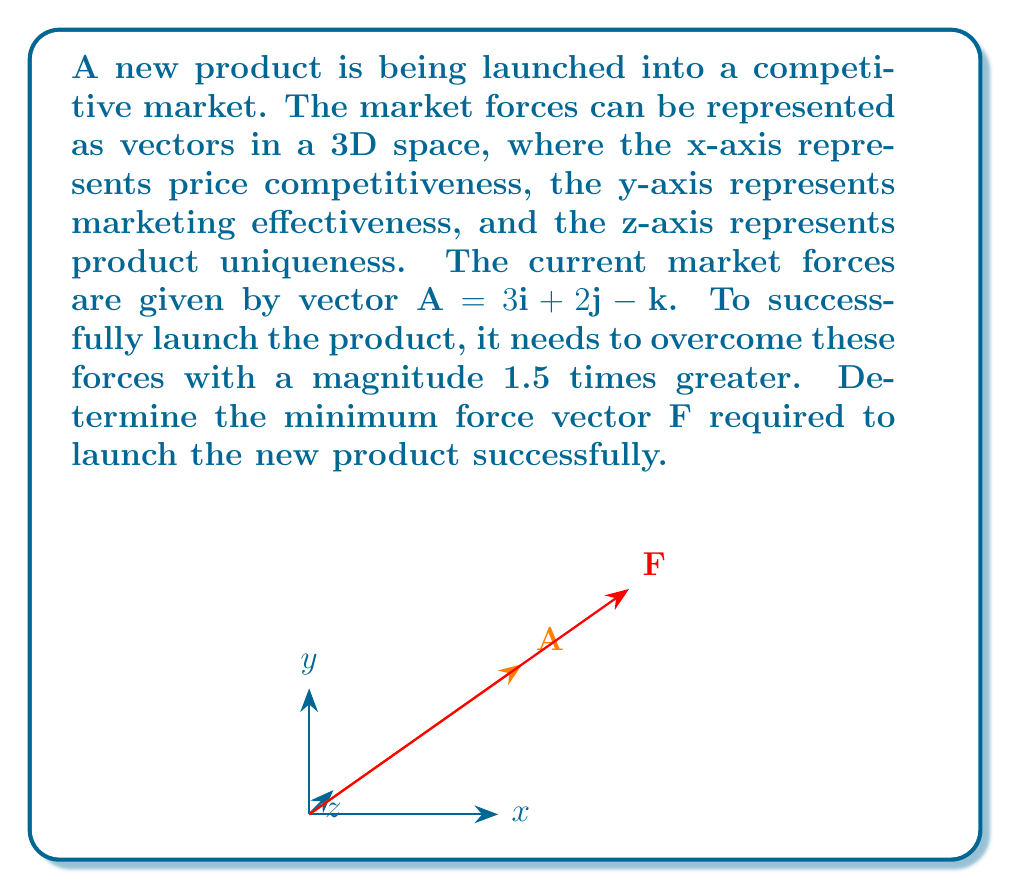Provide a solution to this math problem. Let's approach this step-by-step:

1) First, we need to calculate the magnitude of the current market forces vector $\mathbf{A}$:

   $|\mathbf{A}| = \sqrt{3^2 + 2^2 + (-1)^2} = \sqrt{9 + 4 + 1} = \sqrt{14}$

2) The required force needs to have a magnitude 1.5 times greater than $|\mathbf{A}|$:

   $|\mathbf{F}| = 1.5 \cdot |\mathbf{A}| = 1.5 \cdot \sqrt{14}$

3) To find the components of $\mathbf{F}$, we need to scale each component of $\mathbf{A}$ by the same factor. This factor is the ratio of the magnitudes of $\mathbf{F}$ and $\mathbf{A}$:

   $\text{Scale factor} = \frac{|\mathbf{F}|}{|\mathbf{A}|} = \frac{1.5 \cdot \sqrt{14}}{\sqrt{14}} = 1.5$

4) Now, we can calculate each component of $\mathbf{F}$:

   $F_x = 1.5 \cdot 3 = 4.5$
   $F_y = 1.5 \cdot 2 = 3$
   $F_z = 1.5 \cdot (-1) = -1.5$

5) Therefore, the force vector $\mathbf{F}$ is:

   $\mathbf{F} = 4.5\mathbf{i} + 3\mathbf{j} - 1.5\mathbf{k}$

This vector represents the minimum force required to successfully launch the new product into the competitive market.
Answer: $\mathbf{F} = 4.5\mathbf{i} + 3\mathbf{j} - 1.5\mathbf{k}$ 